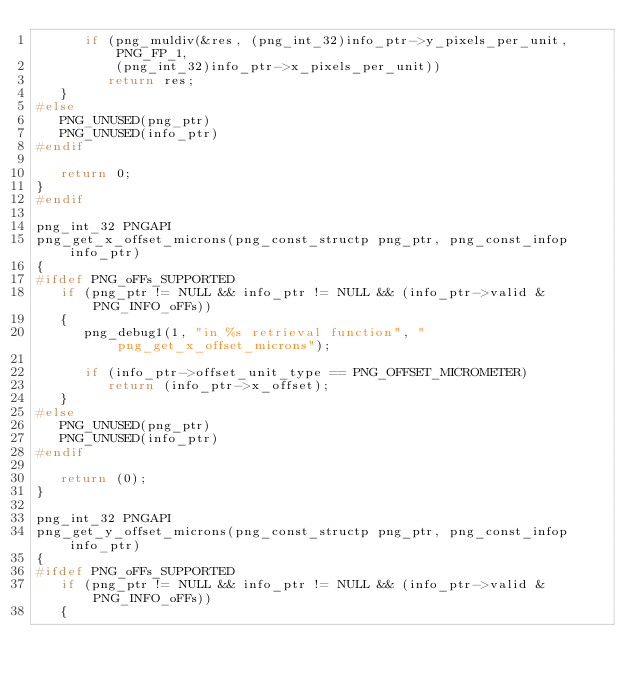<code> <loc_0><loc_0><loc_500><loc_500><_C_>      if (png_muldiv(&res, (png_int_32)info_ptr->y_pixels_per_unit, PNG_FP_1,
          (png_int_32)info_ptr->x_pixels_per_unit))
         return res;
   }
#else
   PNG_UNUSED(png_ptr)
   PNG_UNUSED(info_ptr)
#endif

   return 0;
}
#endif

png_int_32 PNGAPI
png_get_x_offset_microns(png_const_structp png_ptr, png_const_infop info_ptr)
{
#ifdef PNG_oFFs_SUPPORTED
   if (png_ptr != NULL && info_ptr != NULL && (info_ptr->valid & PNG_INFO_oFFs))
   {
      png_debug1(1, "in %s retrieval function", "png_get_x_offset_microns");

      if (info_ptr->offset_unit_type == PNG_OFFSET_MICROMETER)
         return (info_ptr->x_offset);
   }
#else
   PNG_UNUSED(png_ptr)
   PNG_UNUSED(info_ptr)
#endif

   return (0);
}

png_int_32 PNGAPI
png_get_y_offset_microns(png_const_structp png_ptr, png_const_infop info_ptr)
{
#ifdef PNG_oFFs_SUPPORTED
   if (png_ptr != NULL && info_ptr != NULL && (info_ptr->valid & PNG_INFO_oFFs))
   {</code> 